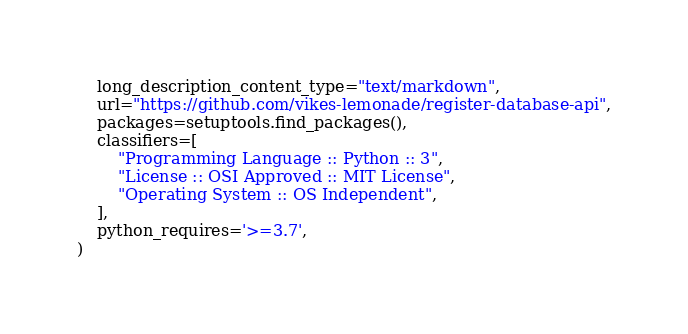<code> <loc_0><loc_0><loc_500><loc_500><_Python_>    long_description_content_type="text/markdown",
    url="https://github.com/vikes-lemonade/register-database-api",
    packages=setuptools.find_packages(),
    classifiers=[
        "Programming Language :: Python :: 3",
        "License :: OSI Approved :: MIT License",
        "Operating System :: OS Independent",
    ],
    python_requires='>=3.7',
)</code> 